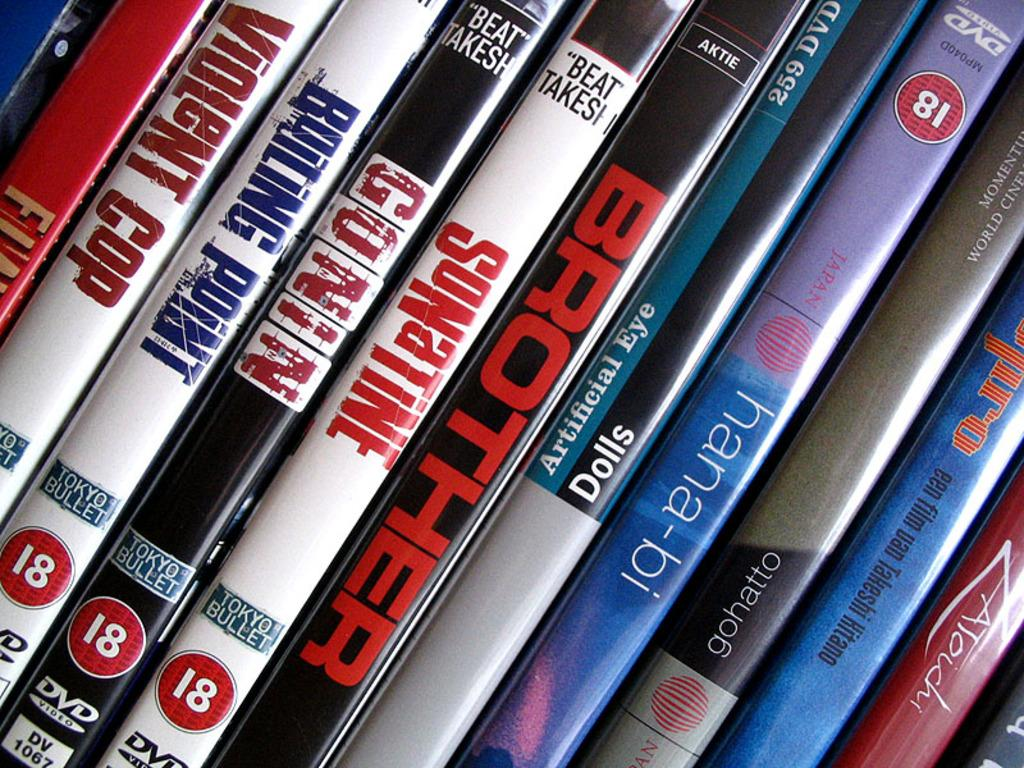<image>
Present a compact description of the photo's key features. A collection of dvds with titles such as Hana-bi, Brother and Sonatine. 